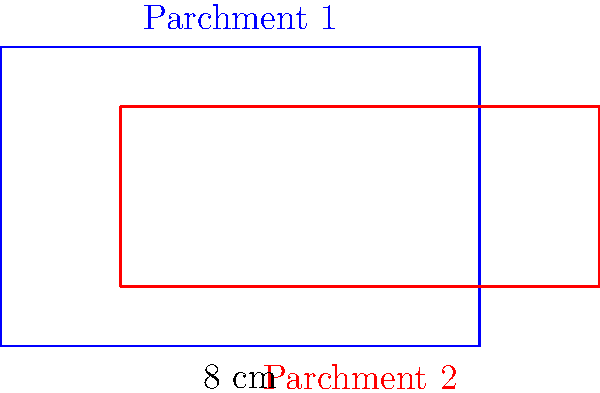While organizing documents from the Reformation era, you come across two rectangular parchments that partially overlap. Parchment 1 measures 8 cm by 5 cm, while Parchment 2 measures 8 cm by 3 cm. If the overlapping region is 6 cm wide and 3 cm tall, what is the total area of both parchments combined (excluding the overlapping area)? To solve this problem, let's follow these steps:

1. Calculate the area of Parchment 1:
   $A_1 = 8 \text{ cm} \times 5 \text{ cm} = 40 \text{ cm}^2$

2. Calculate the area of Parchment 2:
   $A_2 = 8 \text{ cm} \times 3 \text{ cm} = 24 \text{ cm}^2$

3. Calculate the area of the overlapping region:
   $A_{\text{overlap}} = 6 \text{ cm} \times 3 \text{ cm} = 18 \text{ cm}^2$

4. Calculate the total area by adding the areas of both parchments and subtracting the overlapping area:
   $A_{\text{total}} = A_1 + A_2 - A_{\text{overlap}}$
   $A_{\text{total}} = 40 \text{ cm}^2 + 24 \text{ cm}^2 - 18 \text{ cm}^2 = 46 \text{ cm}^2$

Therefore, the total area of both parchments combined, excluding the overlapping area, is 46 cm².
Answer: 46 cm² 